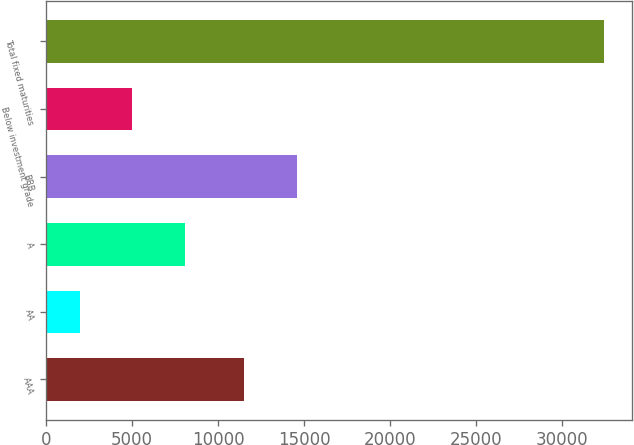Convert chart to OTSL. <chart><loc_0><loc_0><loc_500><loc_500><bar_chart><fcel>AAA<fcel>AA<fcel>A<fcel>BBB<fcel>Below investment grade<fcel>Total fixed maturities<nl><fcel>11510<fcel>1942<fcel>8042<fcel>14560<fcel>4992<fcel>32442<nl></chart> 